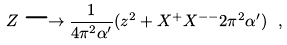Convert formula to latex. <formula><loc_0><loc_0><loc_500><loc_500>Z \longrightarrow \frac { 1 } { 4 \pi ^ { 2 } \alpha ^ { \prime } } ( z ^ { 2 } + X ^ { + } X ^ { - - } 2 \pi ^ { 2 } \alpha ^ { \prime } ) \ ,</formula> 